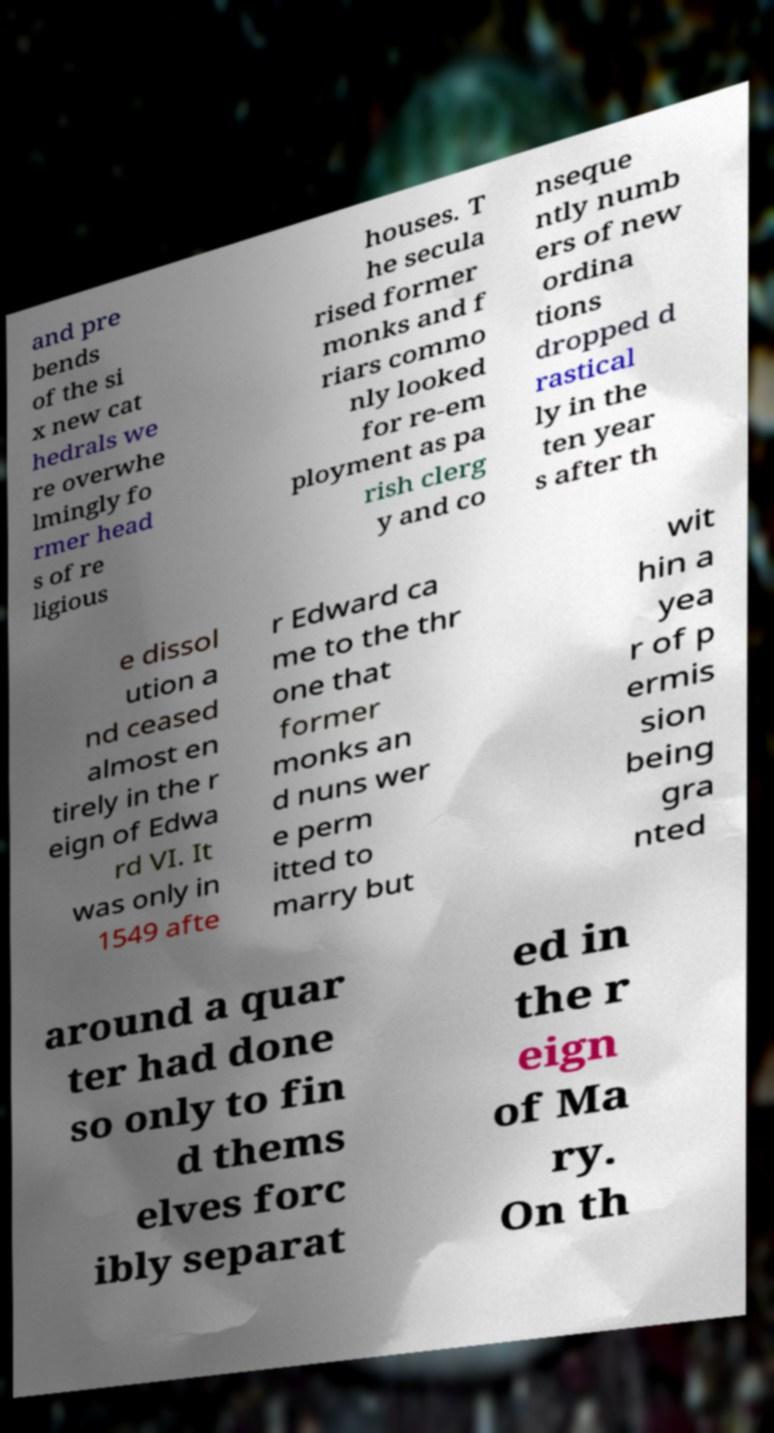I need the written content from this picture converted into text. Can you do that? and pre bends of the si x new cat hedrals we re overwhe lmingly fo rmer head s of re ligious houses. T he secula rised former monks and f riars commo nly looked for re-em ployment as pa rish clerg y and co nseque ntly numb ers of new ordina tions dropped d rastical ly in the ten year s after th e dissol ution a nd ceased almost en tirely in the r eign of Edwa rd VI. It was only in 1549 afte r Edward ca me to the thr one that former monks an d nuns wer e perm itted to marry but wit hin a yea r of p ermis sion being gra nted around a quar ter had done so only to fin d thems elves forc ibly separat ed in the r eign of Ma ry. On th 